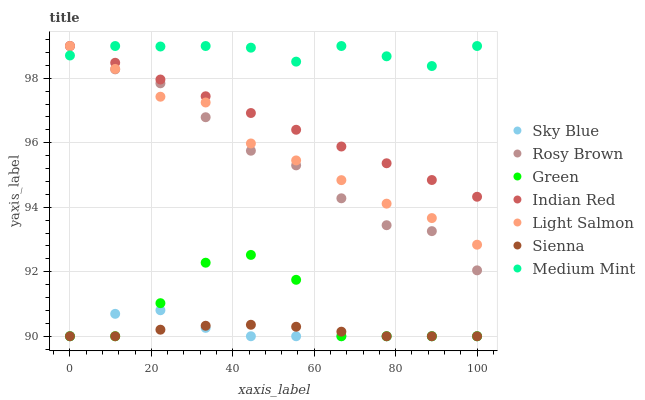Does Sienna have the minimum area under the curve?
Answer yes or no. Yes. Does Medium Mint have the maximum area under the curve?
Answer yes or no. Yes. Does Light Salmon have the minimum area under the curve?
Answer yes or no. No. Does Light Salmon have the maximum area under the curve?
Answer yes or no. No. Is Indian Red the smoothest?
Answer yes or no. Yes. Is Green the roughest?
Answer yes or no. Yes. Is Light Salmon the smoothest?
Answer yes or no. No. Is Light Salmon the roughest?
Answer yes or no. No. Does Sienna have the lowest value?
Answer yes or no. Yes. Does Light Salmon have the lowest value?
Answer yes or no. No. Does Indian Red have the highest value?
Answer yes or no. Yes. Does Sienna have the highest value?
Answer yes or no. No. Is Sienna less than Indian Red?
Answer yes or no. Yes. Is Medium Mint greater than Sienna?
Answer yes or no. Yes. Does Medium Mint intersect Indian Red?
Answer yes or no. Yes. Is Medium Mint less than Indian Red?
Answer yes or no. No. Is Medium Mint greater than Indian Red?
Answer yes or no. No. Does Sienna intersect Indian Red?
Answer yes or no. No. 